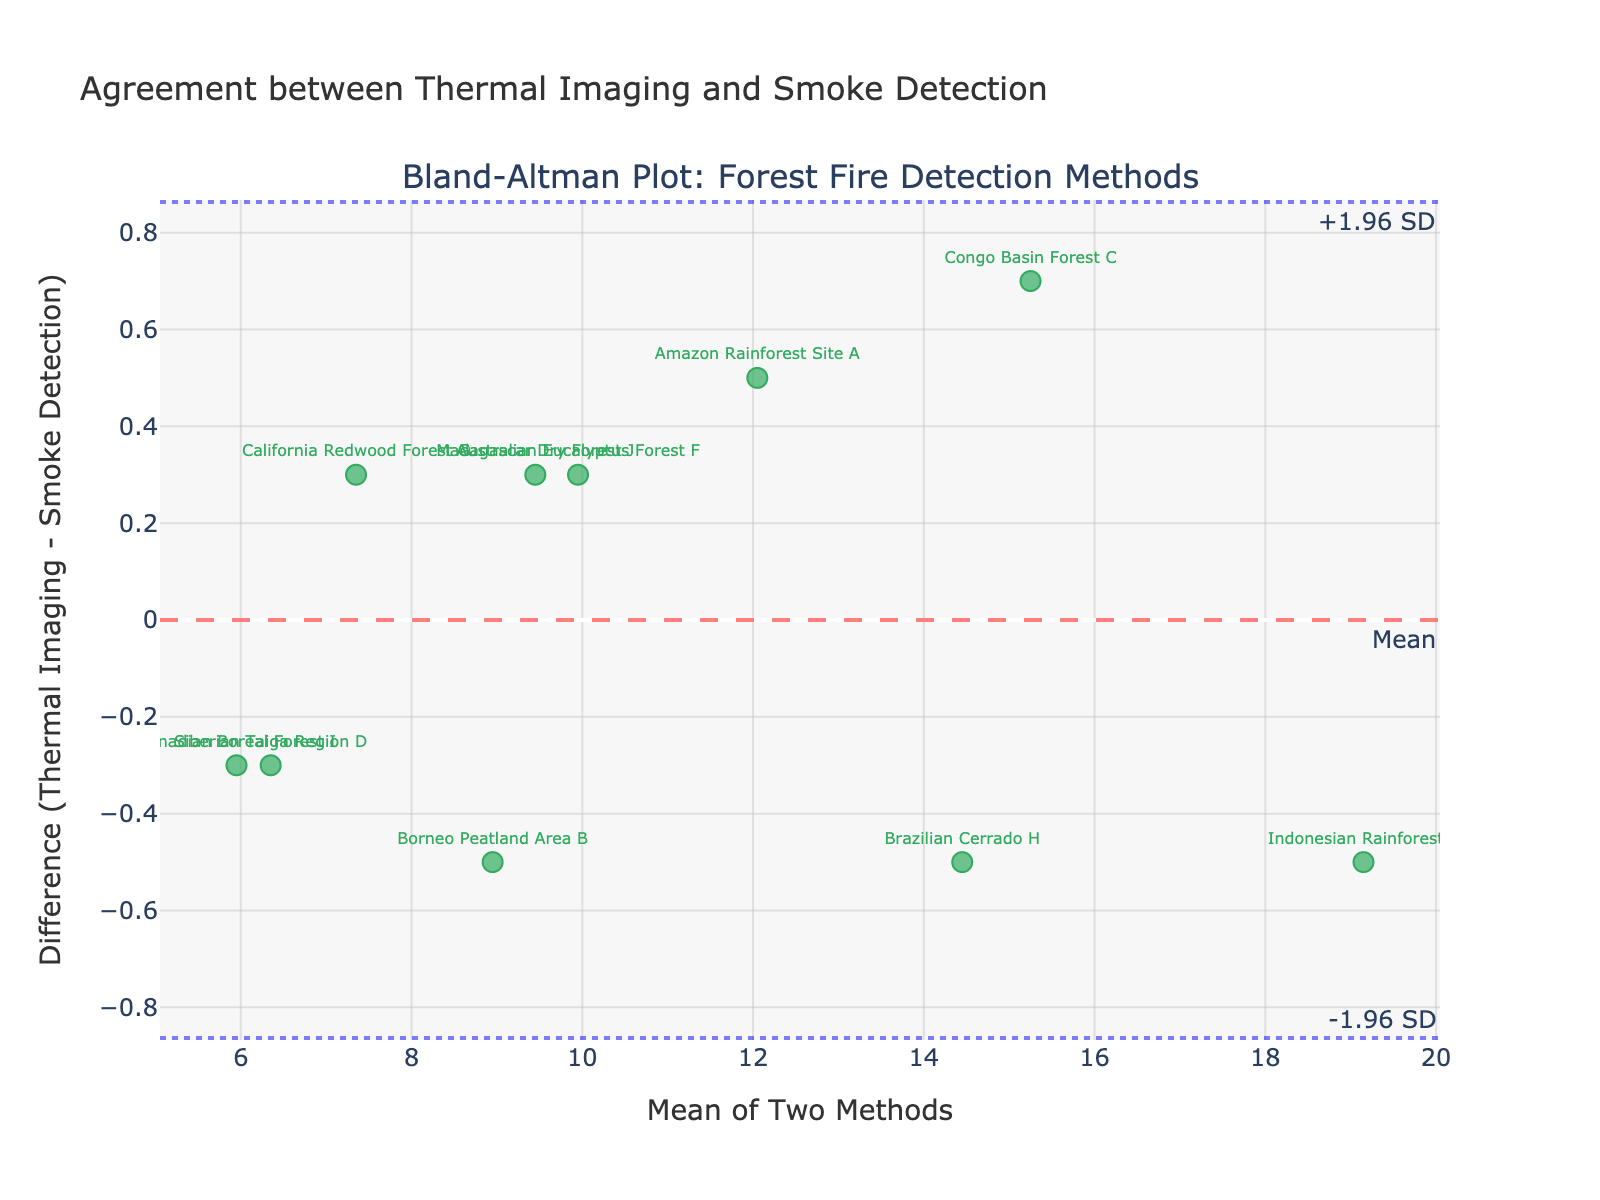what is the title of the plot? The title is located at the top of the figure, typically formatted to be larger and more prominent than other text. It reads "Agreement between Thermal Imaging and Smoke Detection."
Answer: Agreement between Thermal Imaging and Smoke Detection What does the x-axis represent? The x-axis title is labeled "Mean of Two Methods," which indicates it represents the average values of the forest fire detections using thermal imaging and smoke detection.
Answer: Mean of Two Methods How many data points are represented in the plot? Data points are represented by markers on the plot. By counting the markers, there are 10 data points.
Answer: 10 Where is the mean difference line located? The mean difference line is a horizontal dash line labeled "Mean" and it runs through the entire plot horizontally.
Answer: At y=0.0 Which site has the largest positive difference? By examining the markers, the Indonesian Rainforest (E) marker is the highest above the zero line (mean difference line), indicating the largest positive difference.
Answer: Indonesian Rainforest E What are the upper and lower limits of agreement? The upper limit of agreement is visible as a dot line labeled "+1.96 SD," and the lower limit of agreement is labeled "-1.96 SD." These lines indicate the spread of most of the differences.
Answer: Upper limit: 0.924, Lower limit: -1.004 Compare the differences of Amazon Rainforest Site A and Congo Basin Forest C? By examining the plot markers, both sites have differences close to each other but on different sides of the zero line. Amazon Rainforest Site A is slightly below the zero line, and Congo Basin Forest C is slightly above the zero line.
Answer: Amazon Rainforest Site A: -0.5, Congo Basin Forest C: 0.7 Which method detected more fires at the Siberian Taiga Region D, thermal imaging, or smoke detection? For Siberian Taiga Region D, the marker is below the zero line, which indicates thermal imaging detected fewer fires (Thermal Imaging value is lower).
Answer: Smoke Detection What's the average difference between the two methods across all sites? The mean difference (the average of all differences) is indicated by the dash line labeled "Mean" running through the plot.
Answer: -0.04 Are there any points that lie outside the limits of agreement? By looking at the plot, all markers are within the boundaries set by the upper and lower limits of agreement displayed as dot lines (+1.96 SD and -1.96 SD).
Answer: No 